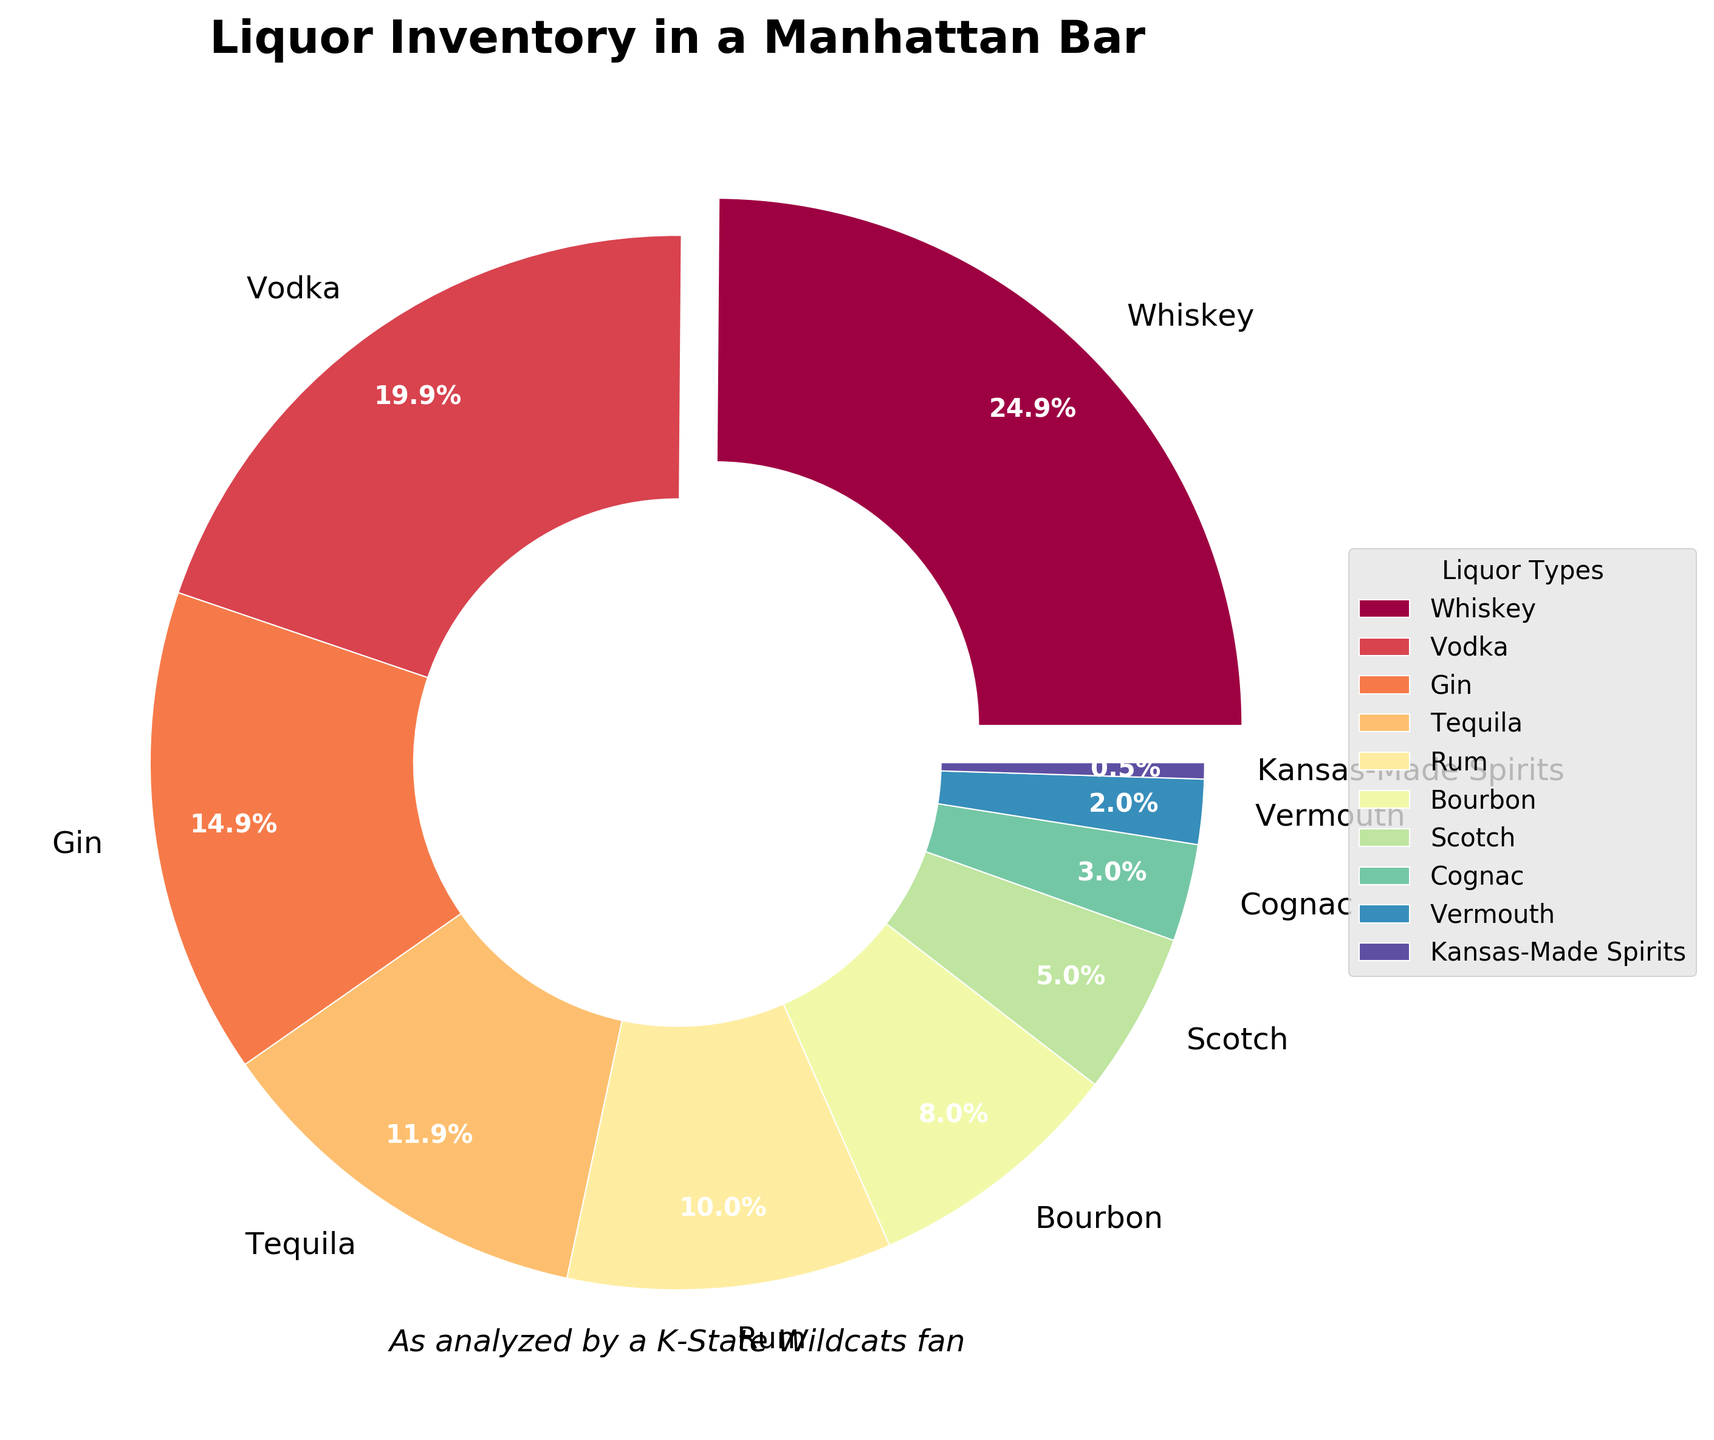Which liquor type takes up the largest percentage of the bar's inventory? By looking at the pie chart, the largest segment is exploded and labeled with its percentage, which makes it easier to identify the largest category.
Answer: Whiskey How much of the bar's inventory is made up of Whiskey and Vodka combined? Add the percentages of Whiskey and Vodka, which are both shown in the pie chart. Whiskey is 25% and Vodka is 20%, thus 25 + 20 = 45%.
Answer: 45% Which liquor type has the smallest percentage in the inventory? The pie chart will show a very small segment for the liquor type with 0.5% labeled as Kansas-Made Spirits.
Answer: Kansas-Made Spirits How does the percentage of Bourbon compare to Scotch? Compare the percentages given in the pie chart for Bourbon and Scotch. Bourbon is 8% and Scotch is 5%. Bourbon is greater than Scotch.
Answer: Bourbon > Scotch What is the total percentage of Gin, Tequila, and Rum in the inventory? Add the percentages of the three liquor types. Gin is 15%, Tequila is 12%, and Rum is 10%, so 15 + 12 + 10 = 37%.
Answer: 37% Is Vermouth’s percentage higher or lower than Cognac’s percentage? Compare the percentages given in the pie chart for Vermouth and Cognac. Vermouth is 2% and Cognac is 3%. Vermouth is lower than Cognac.
Answer: Lower What is the difference in percentage between Vodka and Rum? Subtract the percentage of Rum from the percentage of Vodka. Vodka is 20% and Rum is 10%, so 20 - 10 = 10%.
Answer: 10% What is the combined percentage of all types except Whiskey and Vodka? Subtract the combined percentage of Whiskey and Vodka from 100%. Whiskey is 25% and Vodka is 20%, so combined they are 45%. Thus, 100 - 45 = 55%.
Answer: 55% Which color represents Bourbon in the pie chart? Observing the pie chart legend, identify the corresponding color for the Bourbon label. Bourbon is represented by the specific color shown next to its label.
Answer: The specific color shown in the chart next to Bourbon Does the percentage of Tequila exceed the combined percentage of Vermouth and Kansas-Made Spirits? Compare Tequila's percentage (12%) to the combined percentage of Vermouth (2%) and Kansas-Made Spirits (0.5%). Together Vermouth and Kansas-Made Spirits make 2.5%. 12% is greater than 2.5%.
Answer: Yes 